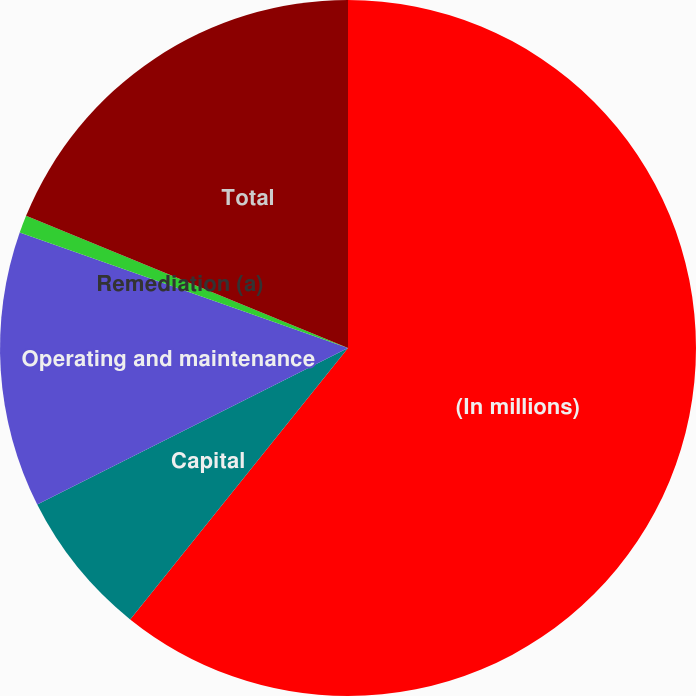Convert chart to OTSL. <chart><loc_0><loc_0><loc_500><loc_500><pie_chart><fcel>(In millions)<fcel>Capital<fcel>Operating and maintenance<fcel>Remediation (a)<fcel>Total<nl><fcel>60.77%<fcel>6.81%<fcel>12.81%<fcel>0.82%<fcel>18.8%<nl></chart> 